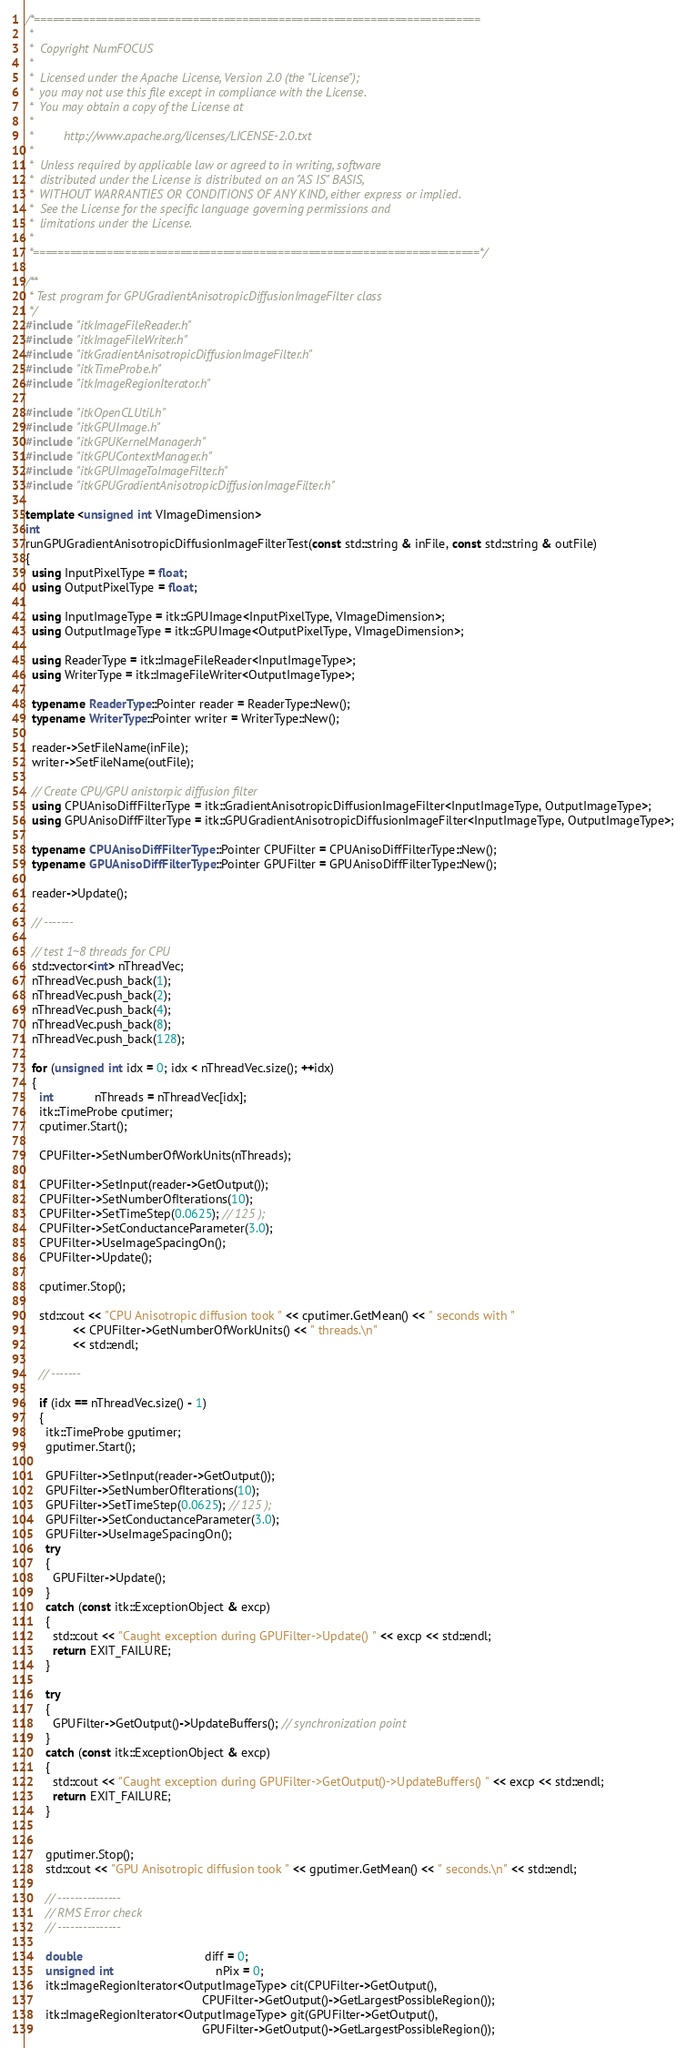<code> <loc_0><loc_0><loc_500><loc_500><_C++_>/*=========================================================================
 *
 *  Copyright NumFOCUS
 *
 *  Licensed under the Apache License, Version 2.0 (the "License");
 *  you may not use this file except in compliance with the License.
 *  You may obtain a copy of the License at
 *
 *         http://www.apache.org/licenses/LICENSE-2.0.txt
 *
 *  Unless required by applicable law or agreed to in writing, software
 *  distributed under the License is distributed on an "AS IS" BASIS,
 *  WITHOUT WARRANTIES OR CONDITIONS OF ANY KIND, either express or implied.
 *  See the License for the specific language governing permissions and
 *  limitations under the License.
 *
 *=========================================================================*/

/**
 * Test program for GPUGradientAnisotropicDiffusionImageFilter class
 */
#include "itkImageFileReader.h"
#include "itkImageFileWriter.h"
#include "itkGradientAnisotropicDiffusionImageFilter.h"
#include "itkTimeProbe.h"
#include "itkImageRegionIterator.h"

#include "itkOpenCLUtil.h"
#include "itkGPUImage.h"
#include "itkGPUKernelManager.h"
#include "itkGPUContextManager.h"
#include "itkGPUImageToImageFilter.h"
#include "itkGPUGradientAnisotropicDiffusionImageFilter.h"

template <unsigned int VImageDimension>
int
runGPUGradientAnisotropicDiffusionImageFilterTest(const std::string & inFile, const std::string & outFile)
{
  using InputPixelType = float;
  using OutputPixelType = float;

  using InputImageType = itk::GPUImage<InputPixelType, VImageDimension>;
  using OutputImageType = itk::GPUImage<OutputPixelType, VImageDimension>;

  using ReaderType = itk::ImageFileReader<InputImageType>;
  using WriterType = itk::ImageFileWriter<OutputImageType>;

  typename ReaderType::Pointer reader = ReaderType::New();
  typename WriterType::Pointer writer = WriterType::New();

  reader->SetFileName(inFile);
  writer->SetFileName(outFile);

  // Create CPU/GPU anistorpic diffusion filter
  using CPUAnisoDiffFilterType = itk::GradientAnisotropicDiffusionImageFilter<InputImageType, OutputImageType>;
  using GPUAnisoDiffFilterType = itk::GPUGradientAnisotropicDiffusionImageFilter<InputImageType, OutputImageType>;

  typename CPUAnisoDiffFilterType::Pointer CPUFilter = CPUAnisoDiffFilterType::New();
  typename GPUAnisoDiffFilterType::Pointer GPUFilter = GPUAnisoDiffFilterType::New();

  reader->Update();

  // -------

  // test 1~8 threads for CPU
  std::vector<int> nThreadVec;
  nThreadVec.push_back(1);
  nThreadVec.push_back(2);
  nThreadVec.push_back(4);
  nThreadVec.push_back(8);
  nThreadVec.push_back(128);

  for (unsigned int idx = 0; idx < nThreadVec.size(); ++idx)
  {
    int            nThreads = nThreadVec[idx];
    itk::TimeProbe cputimer;
    cputimer.Start();

    CPUFilter->SetNumberOfWorkUnits(nThreads);

    CPUFilter->SetInput(reader->GetOutput());
    CPUFilter->SetNumberOfIterations(10);
    CPUFilter->SetTimeStep(0.0625); // 125 );
    CPUFilter->SetConductanceParameter(3.0);
    CPUFilter->UseImageSpacingOn();
    CPUFilter->Update();

    cputimer.Stop();

    std::cout << "CPU Anisotropic diffusion took " << cputimer.GetMean() << " seconds with "
              << CPUFilter->GetNumberOfWorkUnits() << " threads.\n"
              << std::endl;

    // -------

    if (idx == nThreadVec.size() - 1)
    {
      itk::TimeProbe gputimer;
      gputimer.Start();

      GPUFilter->SetInput(reader->GetOutput());
      GPUFilter->SetNumberOfIterations(10);
      GPUFilter->SetTimeStep(0.0625); // 125 );
      GPUFilter->SetConductanceParameter(3.0);
      GPUFilter->UseImageSpacingOn();
      try
      {
        GPUFilter->Update();
      }
      catch (const itk::ExceptionObject & excp)
      {
        std::cout << "Caught exception during GPUFilter->Update() " << excp << std::endl;
        return EXIT_FAILURE;
      }

      try
      {
        GPUFilter->GetOutput()->UpdateBuffers(); // synchronization point
      }
      catch (const itk::ExceptionObject & excp)
      {
        std::cout << "Caught exception during GPUFilter->GetOutput()->UpdateBuffers() " << excp << std::endl;
        return EXIT_FAILURE;
      }


      gputimer.Stop();
      std::cout << "GPU Anisotropic diffusion took " << gputimer.GetMean() << " seconds.\n" << std::endl;

      // ---------------
      // RMS Error check
      // ---------------

      double                                    diff = 0;
      unsigned int                              nPix = 0;
      itk::ImageRegionIterator<OutputImageType> cit(CPUFilter->GetOutput(),
                                                    CPUFilter->GetOutput()->GetLargestPossibleRegion());
      itk::ImageRegionIterator<OutputImageType> git(GPUFilter->GetOutput(),
                                                    GPUFilter->GetOutput()->GetLargestPossibleRegion());
</code> 